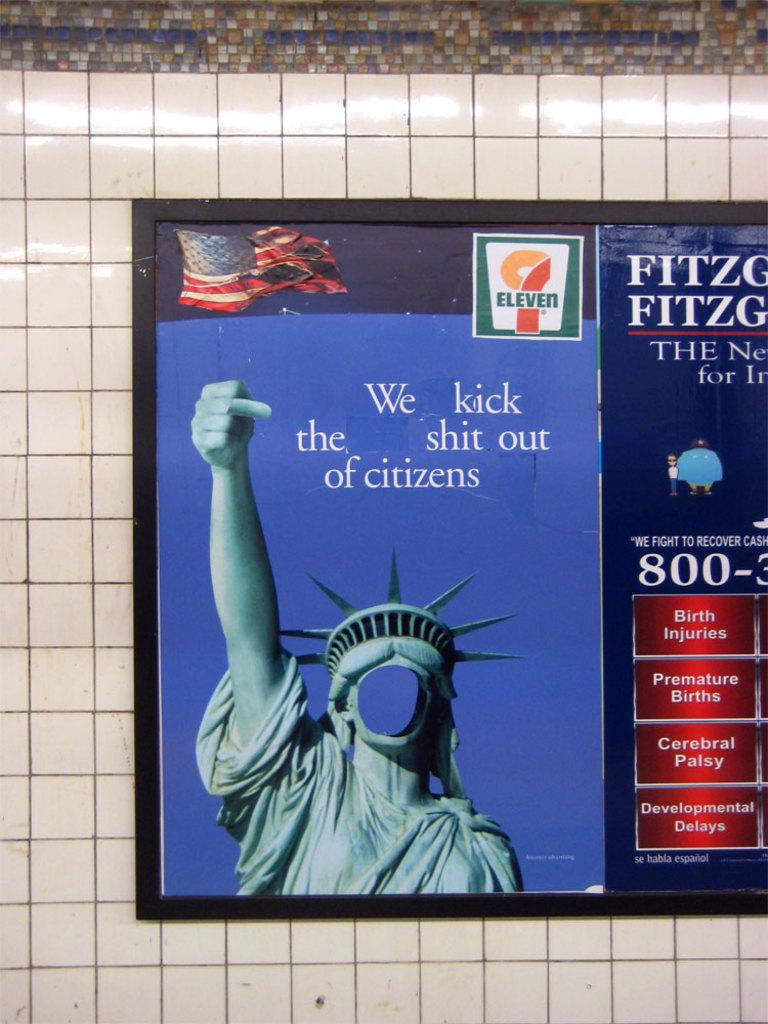<image>
Render a clear and concise summary of the photo. A faceless Statute of Liberty is giving the finger next to a brochure about birth injuries. 